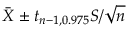<formula> <loc_0><loc_0><loc_500><loc_500>{ \bar { X } } \pm t _ { n - 1 , 0 . 9 7 5 } S / { \sqrt { n } }</formula> 